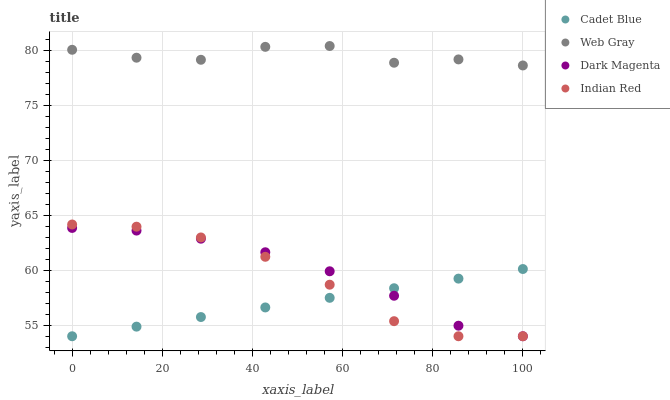Does Cadet Blue have the minimum area under the curve?
Answer yes or no. Yes. Does Web Gray have the maximum area under the curve?
Answer yes or no. Yes. Does Dark Magenta have the minimum area under the curve?
Answer yes or no. No. Does Dark Magenta have the maximum area under the curve?
Answer yes or no. No. Is Cadet Blue the smoothest?
Answer yes or no. Yes. Is Web Gray the roughest?
Answer yes or no. Yes. Is Dark Magenta the smoothest?
Answer yes or no. No. Is Dark Magenta the roughest?
Answer yes or no. No. Does Cadet Blue have the lowest value?
Answer yes or no. Yes. Does Web Gray have the lowest value?
Answer yes or no. No. Does Web Gray have the highest value?
Answer yes or no. Yes. Does Dark Magenta have the highest value?
Answer yes or no. No. Is Cadet Blue less than Web Gray?
Answer yes or no. Yes. Is Web Gray greater than Cadet Blue?
Answer yes or no. Yes. Does Cadet Blue intersect Dark Magenta?
Answer yes or no. Yes. Is Cadet Blue less than Dark Magenta?
Answer yes or no. No. Is Cadet Blue greater than Dark Magenta?
Answer yes or no. No. Does Cadet Blue intersect Web Gray?
Answer yes or no. No. 